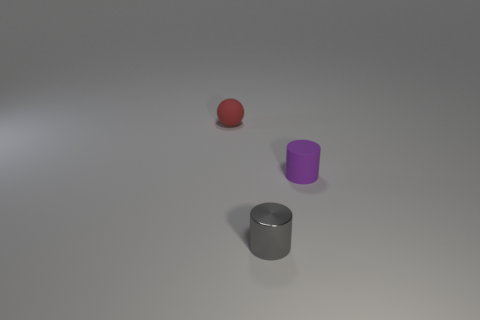Add 2 cylinders. How many objects exist? 5 Subtract 0 blue cubes. How many objects are left? 3 Subtract all balls. How many objects are left? 2 Subtract 1 cylinders. How many cylinders are left? 1 Subtract all brown balls. Subtract all green cylinders. How many balls are left? 1 Subtract all cyan cubes. How many purple cylinders are left? 1 Subtract all rubber spheres. Subtract all shiny cylinders. How many objects are left? 1 Add 2 tiny cylinders. How many tiny cylinders are left? 4 Add 1 tiny metallic things. How many tiny metallic things exist? 2 Subtract all purple cylinders. How many cylinders are left? 1 